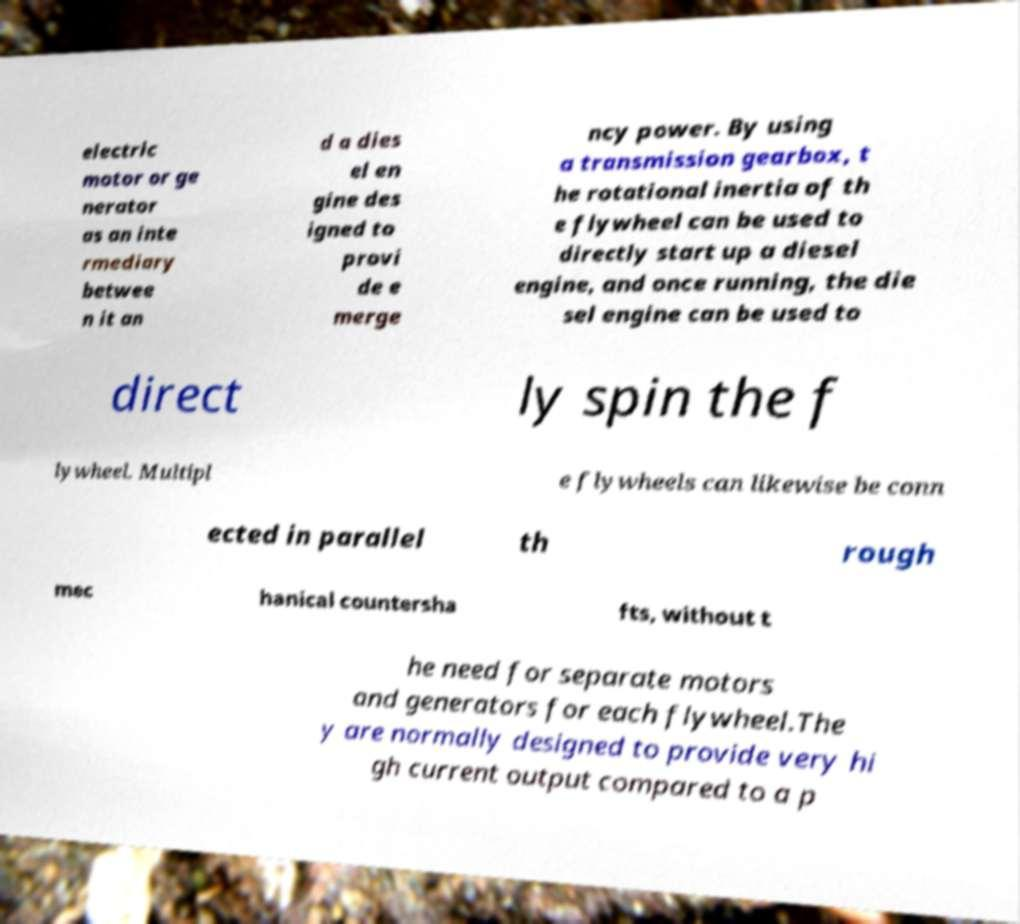Could you extract and type out the text from this image? electric motor or ge nerator as an inte rmediary betwee n it an d a dies el en gine des igned to provi de e merge ncy power. By using a transmission gearbox, t he rotational inertia of th e flywheel can be used to directly start up a diesel engine, and once running, the die sel engine can be used to direct ly spin the f lywheel. Multipl e flywheels can likewise be conn ected in parallel th rough mec hanical countersha fts, without t he need for separate motors and generators for each flywheel.The y are normally designed to provide very hi gh current output compared to a p 